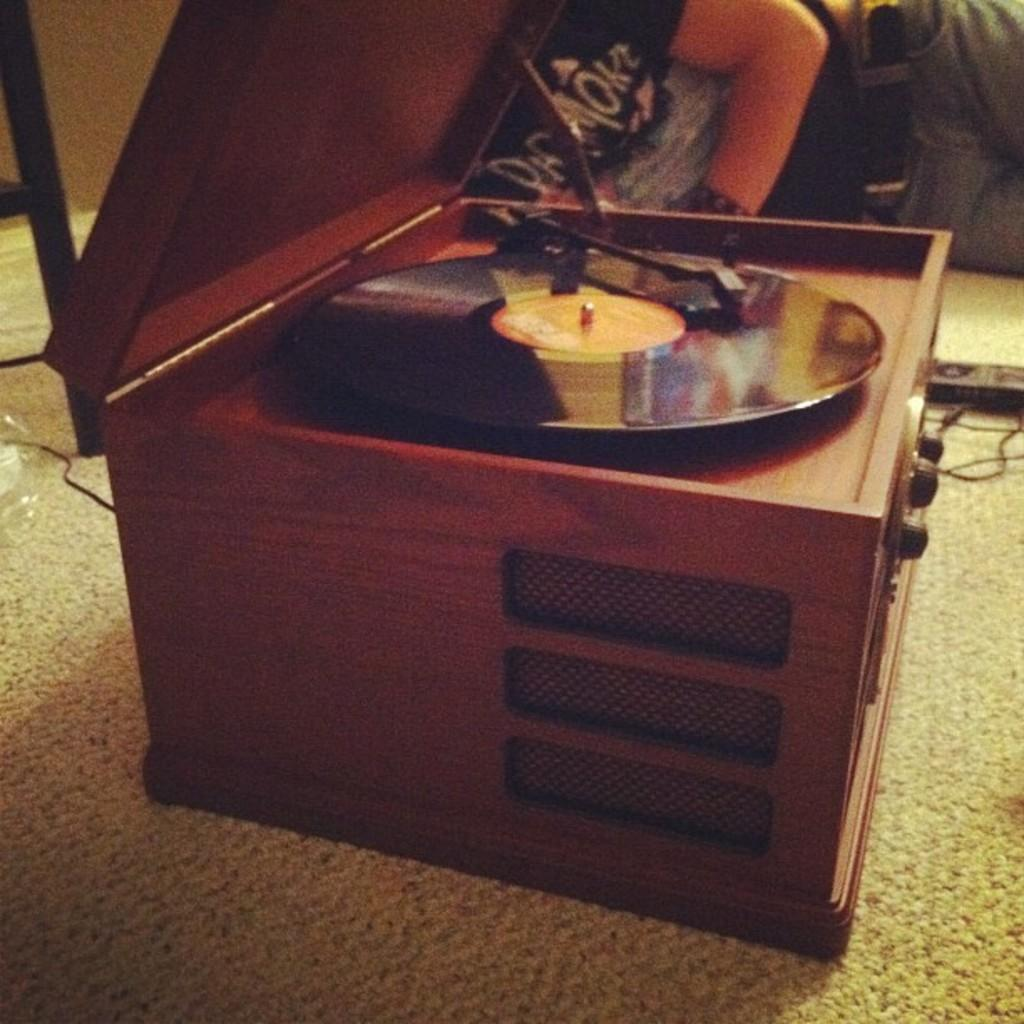What object is the main focus of the image? There is a music box in the image. What material is the music box made of? The music box is made of wood. Where is the music box located in the image? The music box is on the floor. Who is present in the image? There is a person in the image. What is the person doing in the image? The person is sitting on the floor. What is the person wearing in the image? The person is wearing a black t-shirt. What time of day is it in the image, and what pot is being used for cooking? The provided facts do not mention the time of day or any pot being used for cooking. 